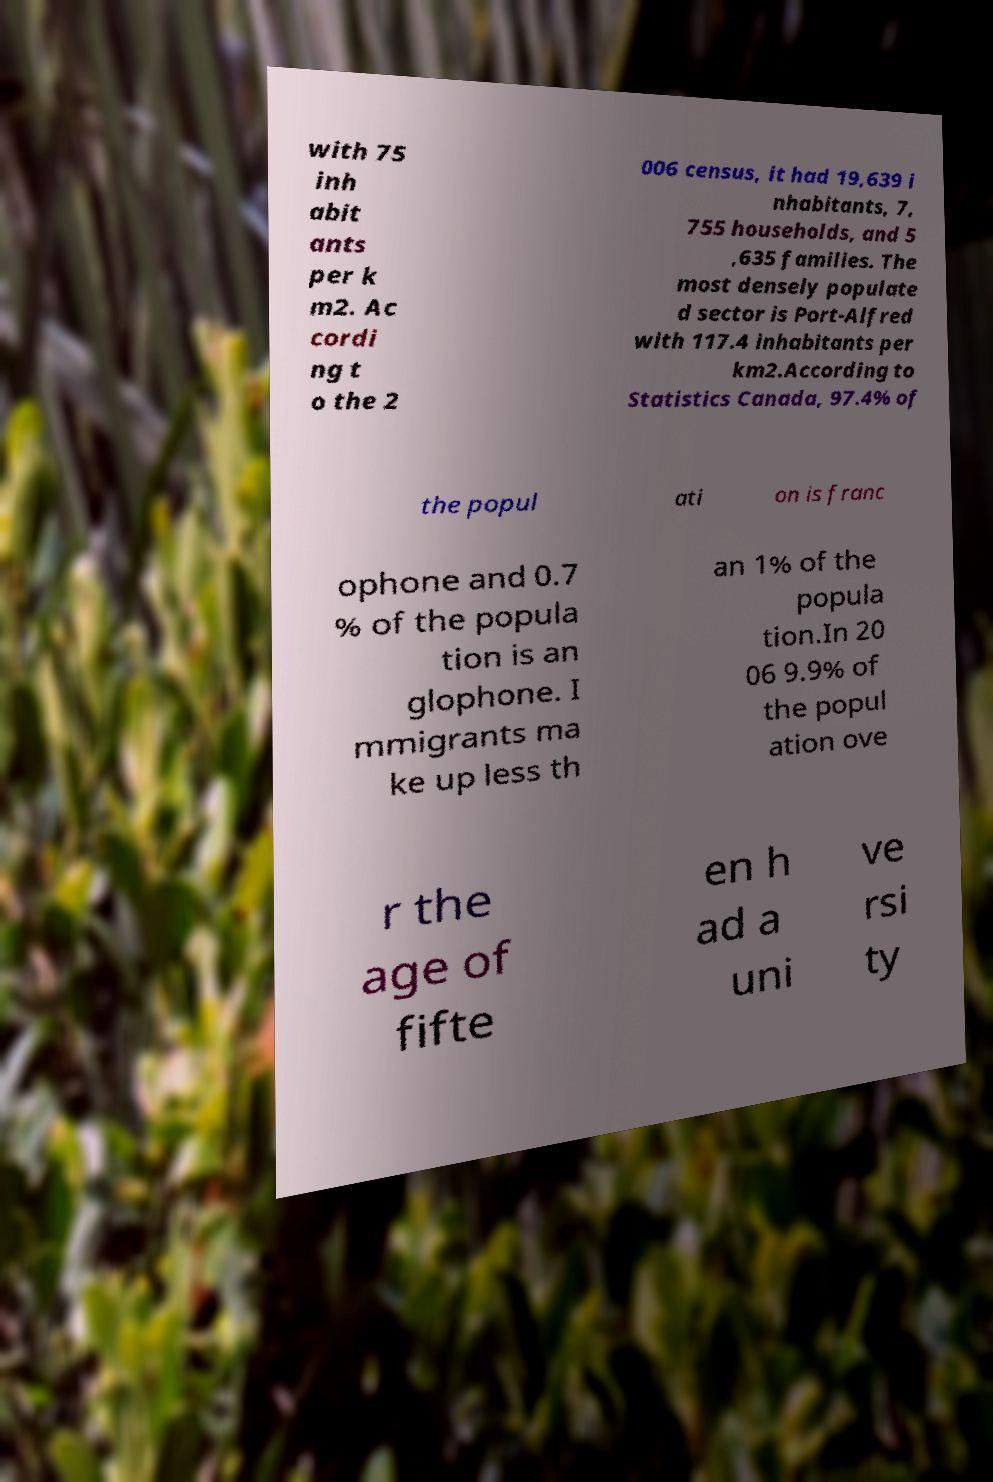Please read and relay the text visible in this image. What does it say? with 75 inh abit ants per k m2. Ac cordi ng t o the 2 006 census, it had 19,639 i nhabitants, 7, 755 households, and 5 ,635 families. The most densely populate d sector is Port-Alfred with 117.4 inhabitants per km2.According to Statistics Canada, 97.4% of the popul ati on is franc ophone and 0.7 % of the popula tion is an glophone. I mmigrants ma ke up less th an 1% of the popula tion.In 20 06 9.9% of the popul ation ove r the age of fifte en h ad a uni ve rsi ty 